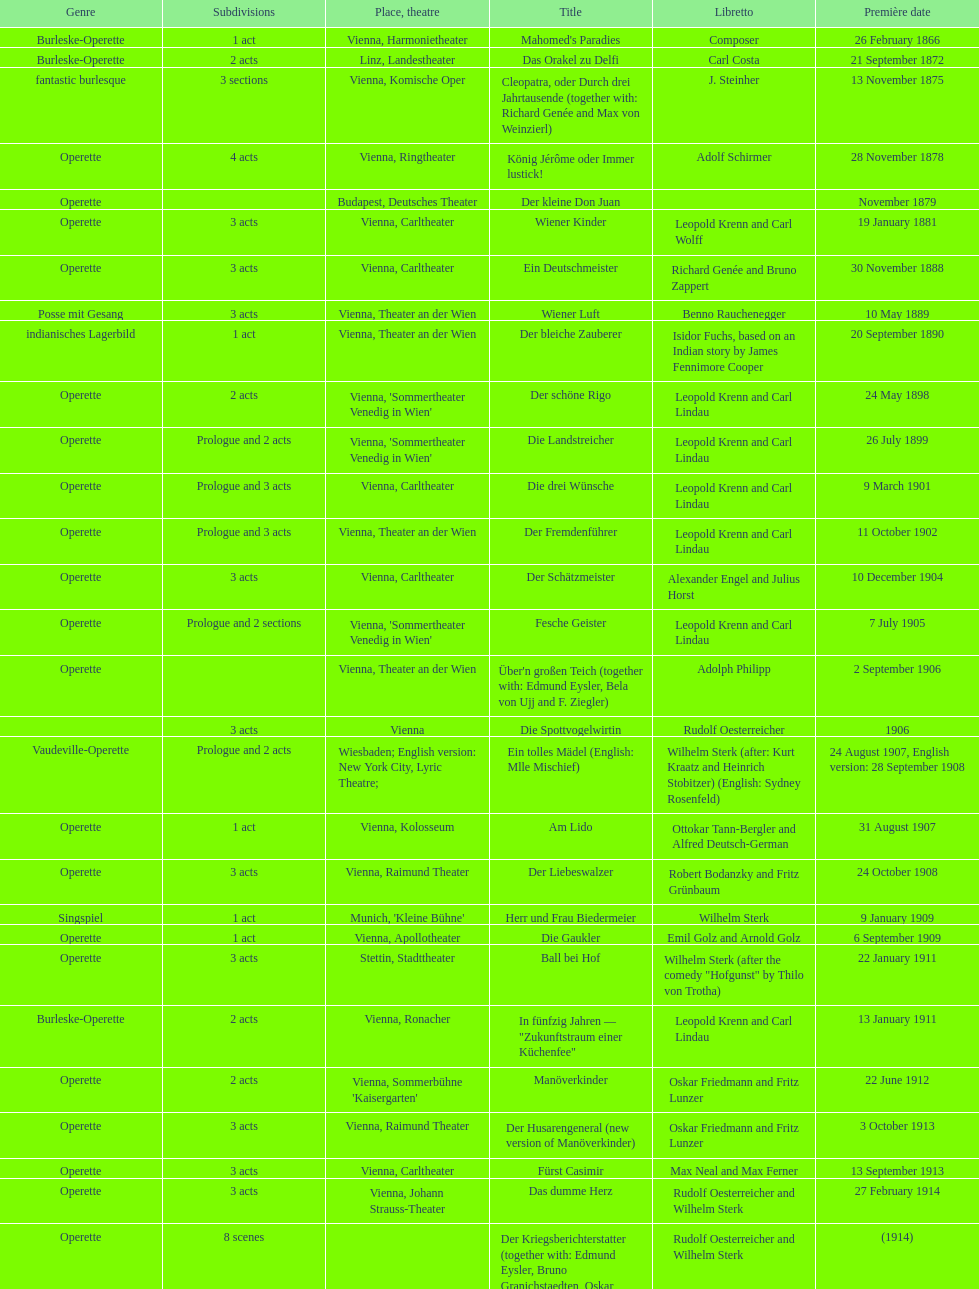How many number of 1 acts were there? 5. 